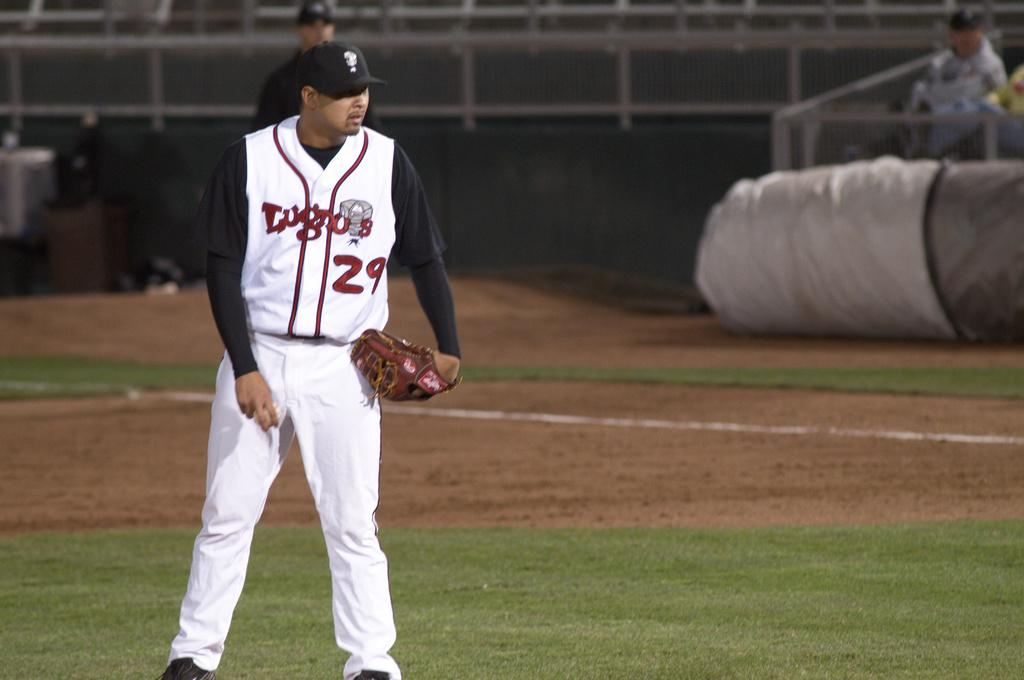<image>
Render a clear and concise summary of the photo. A baseball player wearing a number 29 Lugnos jersey stands holding a baseball. 